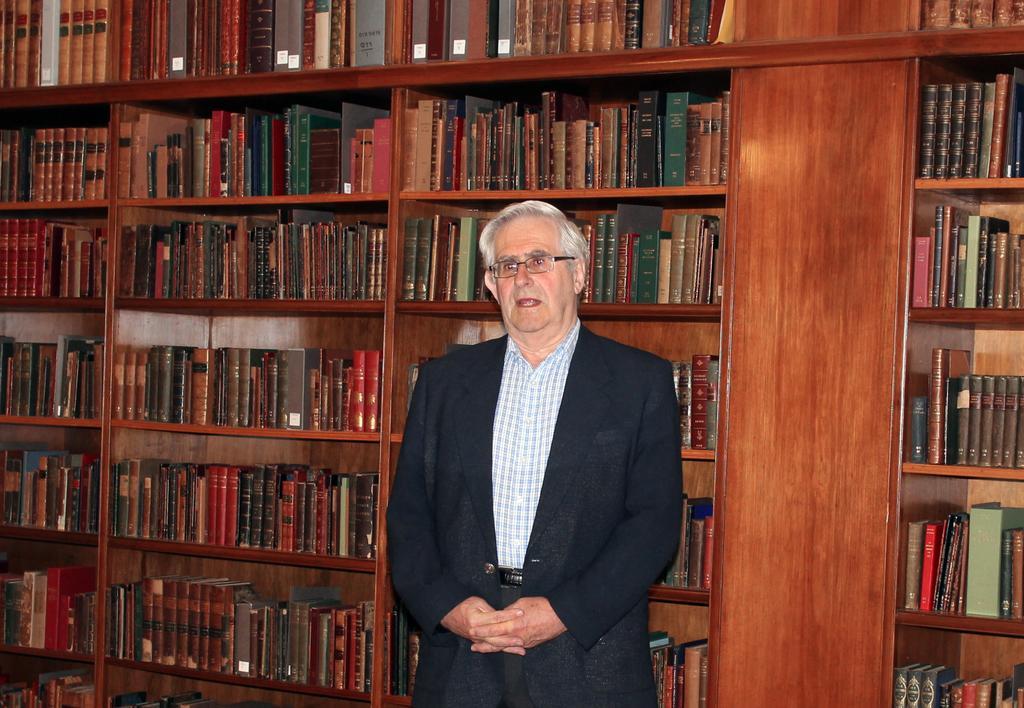Please provide a concise description of this image. In the center of the image we can see a man standing. On the backside we can see a group of books which are placed in an order in the shelves. 